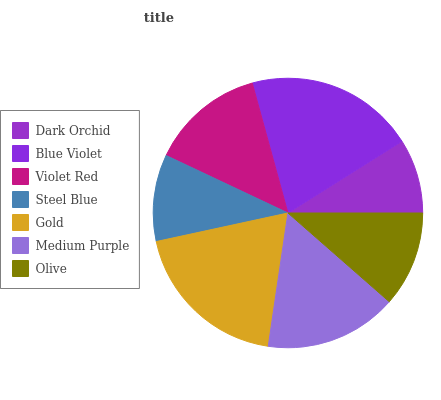Is Dark Orchid the minimum?
Answer yes or no. Yes. Is Blue Violet the maximum?
Answer yes or no. Yes. Is Violet Red the minimum?
Answer yes or no. No. Is Violet Red the maximum?
Answer yes or no. No. Is Blue Violet greater than Violet Red?
Answer yes or no. Yes. Is Violet Red less than Blue Violet?
Answer yes or no. Yes. Is Violet Red greater than Blue Violet?
Answer yes or no. No. Is Blue Violet less than Violet Red?
Answer yes or no. No. Is Violet Red the high median?
Answer yes or no. Yes. Is Violet Red the low median?
Answer yes or no. Yes. Is Blue Violet the high median?
Answer yes or no. No. Is Olive the low median?
Answer yes or no. No. 